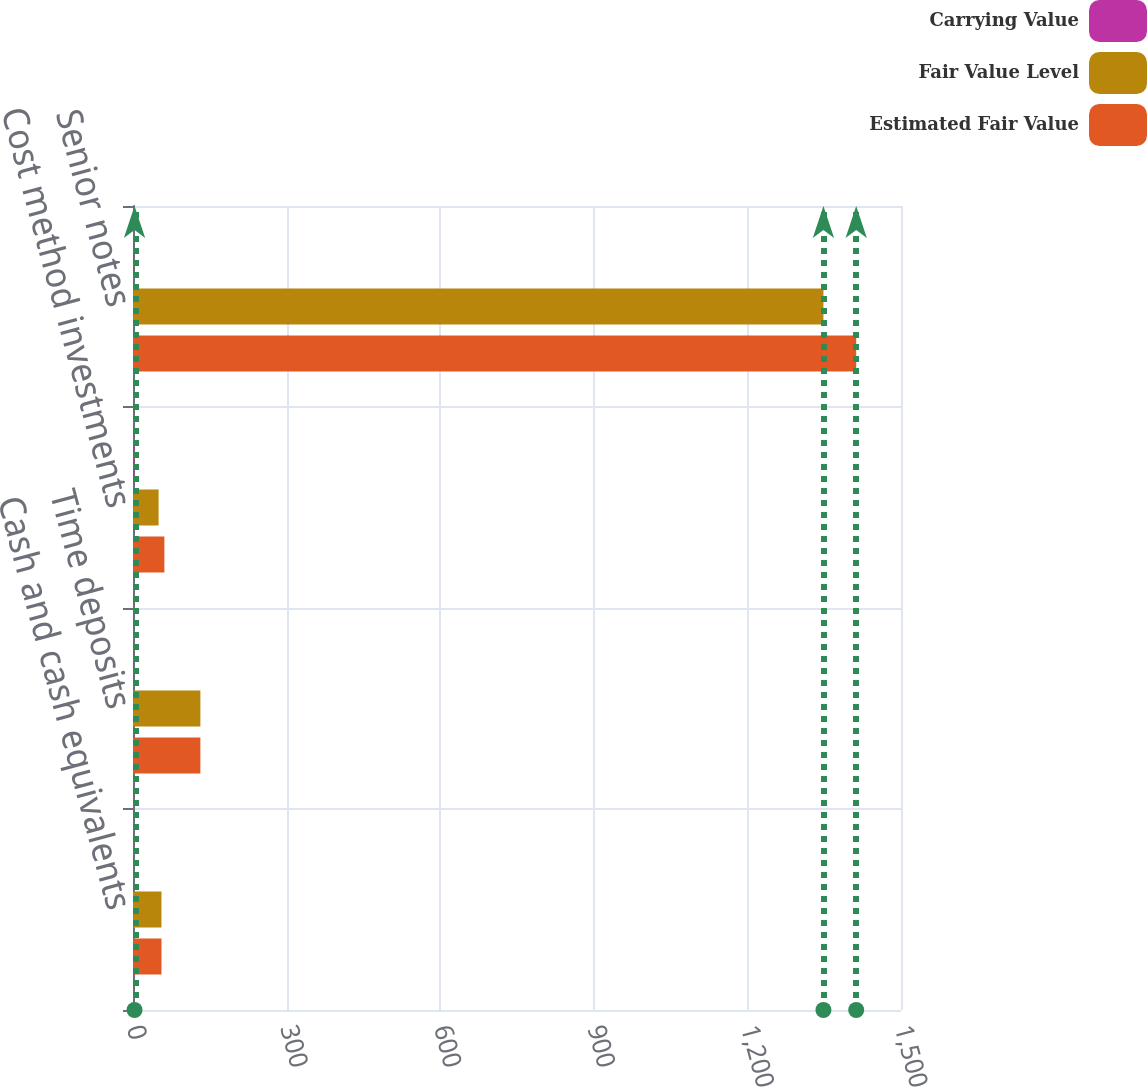Convert chart to OTSL. <chart><loc_0><loc_0><loc_500><loc_500><stacked_bar_chart><ecel><fcel>Cash and cash equivalents<fcel>Time deposits<fcel>Cost method investments<fcel>Senior notes<nl><fcel>Carrying Value<fcel>1<fcel>2<fcel>3<fcel>2<nl><fcel>Fair Value Level<fcel>55.65<fcel>131.6<fcel>50<fcel>1348.5<nl><fcel>Estimated Fair Value<fcel>55.65<fcel>131.6<fcel>61.3<fcel>1412.5<nl></chart> 